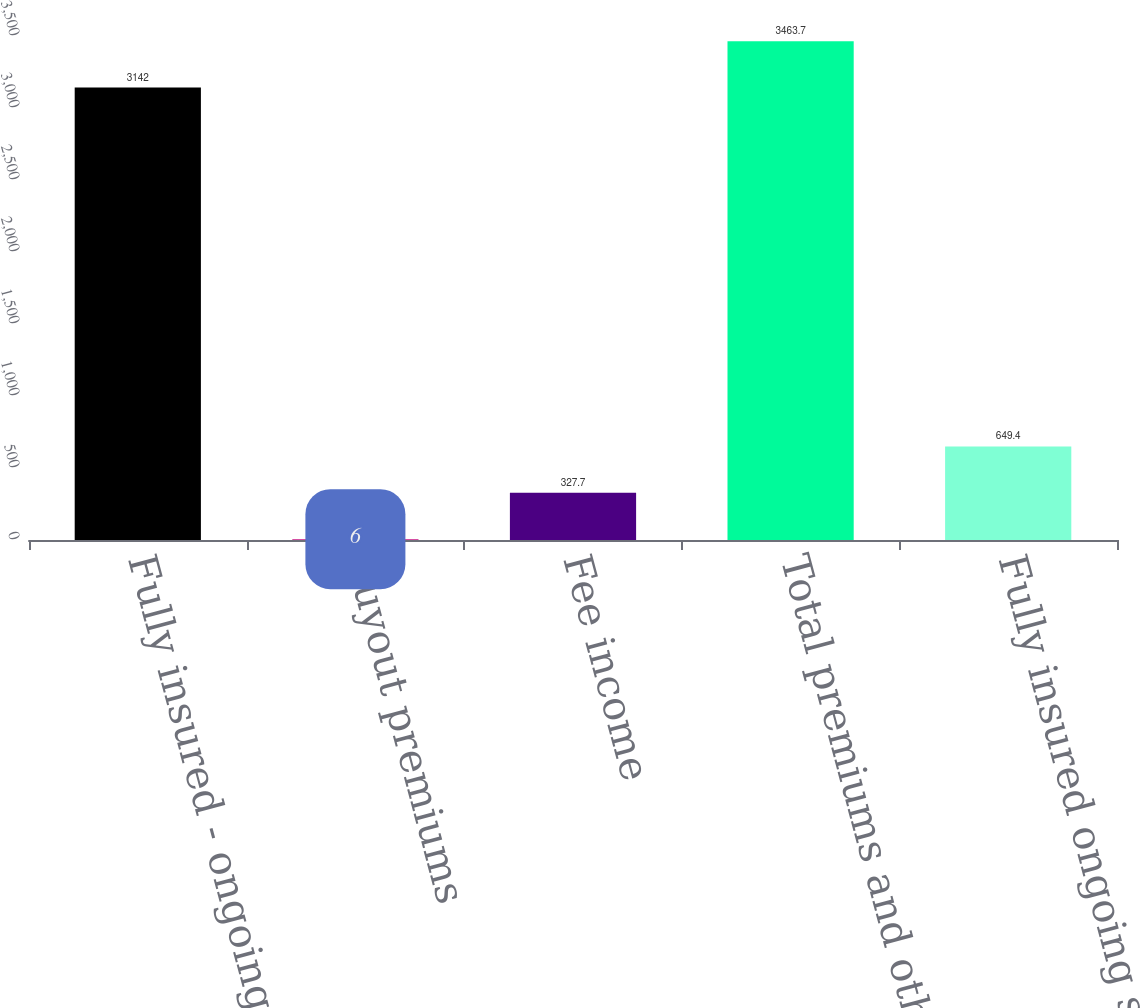Convert chart. <chart><loc_0><loc_0><loc_500><loc_500><bar_chart><fcel>Fully insured - ongoing<fcel>Buyout premiums<fcel>Fee income<fcel>Total premiums and other<fcel>Fully insured ongoing sales<nl><fcel>3142<fcel>6<fcel>327.7<fcel>3463.7<fcel>649.4<nl></chart> 